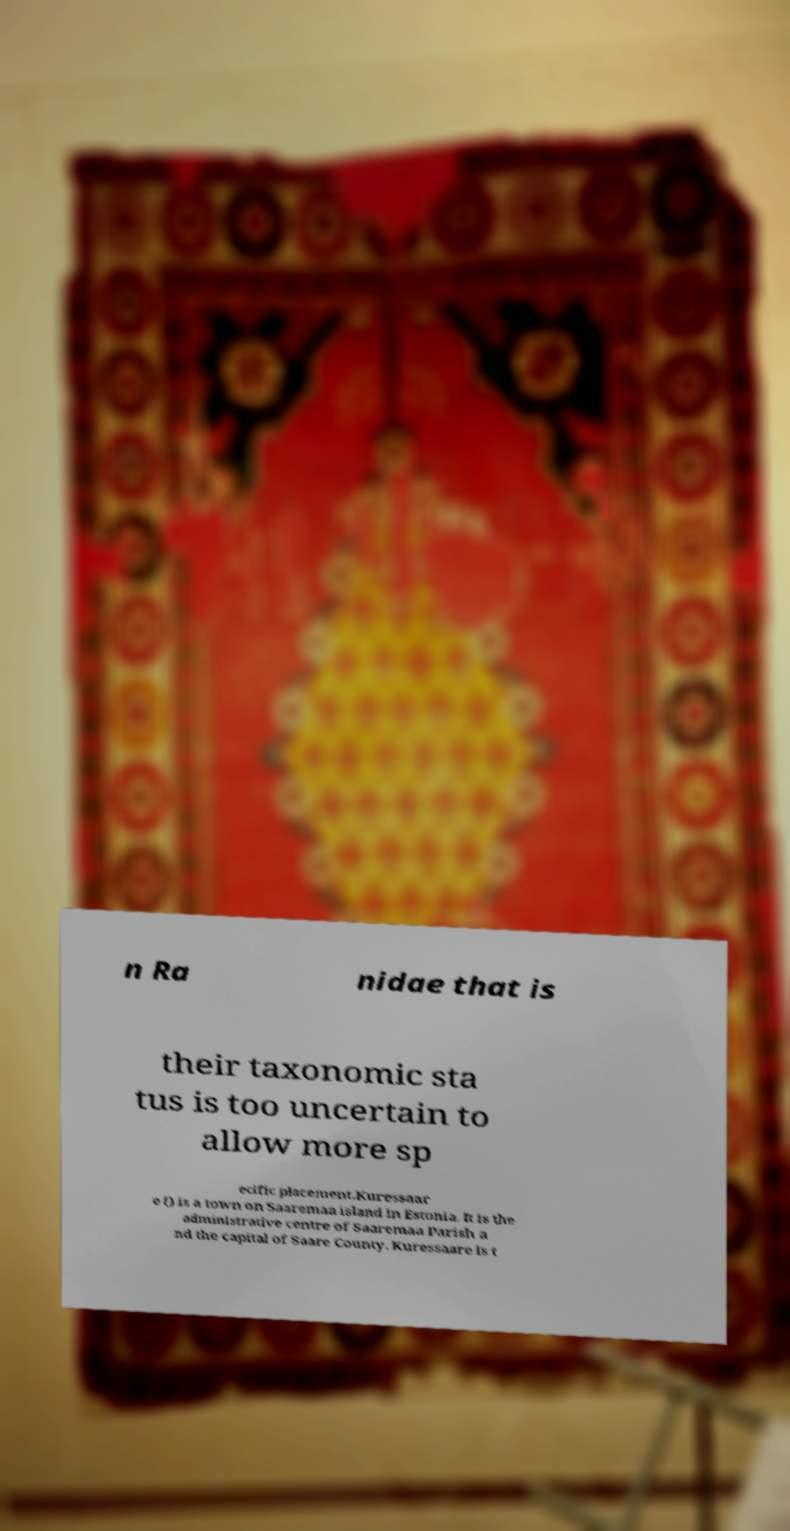Please read and relay the text visible in this image. What does it say? n Ra nidae that is their taxonomic sta tus is too uncertain to allow more sp ecific placement.Kuressaar e () is a town on Saaremaa island in Estonia. It is the administrative centre of Saaremaa Parish a nd the capital of Saare County. Kuressaare is t 